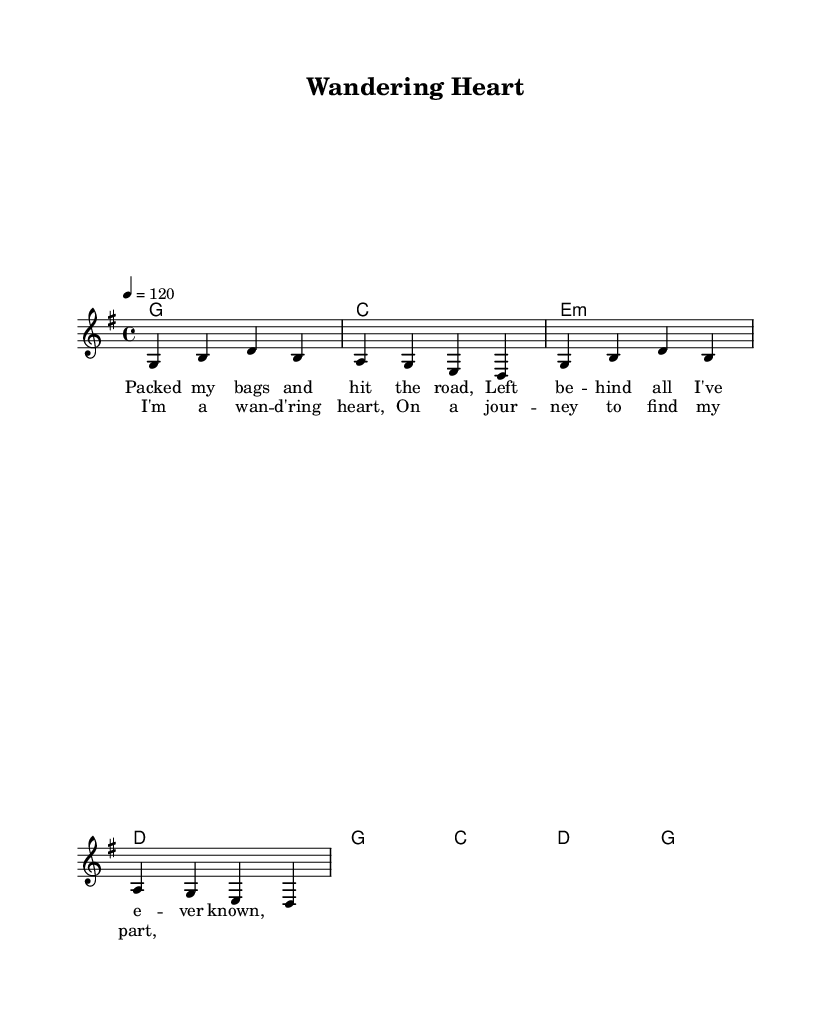What is the key signature of this music? The key signature is G major, which has one sharp note (F#). This can be identified in the music sheet where the key is denoted before the time signature.
Answer: G major What is the time signature of this music? The time signature is 4/4, which indicates four beats per measure and a quarter note receives one beat. This is explicitly stated in the sheet music representation.
Answer: 4/4 What is the tempo of this music? The tempo is set at 120 beats per minute, as noted in the tempo marking at the beginning of the score. This indicates how fast the music should be played.
Answer: 120 How many bars are in the chorus section? The chorus section spans 4 bars, which can be counted in the provided melody and harmony sections explicitly labeled as the chorus.
Answer: 4 What is the first chord in the harmony? The first chord in the harmony is G major, which can be identified as the first chord in the chord progression provided in the sheet music.
Answer: G What is the lyrical theme of the song? The lyrical theme centers around adventure and self-discovery, as indicated in the lyrics provided that describe packing bags and hitting the road.
Answer: Adventure Which musical genre does this piece belong to? This piece belongs to the Country Rock genre, as indicated by its stylistic features and the thematic content of self-discovery and journeying.
Answer: Country Rock 